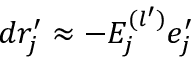<formula> <loc_0><loc_0><loc_500><loc_500>d r _ { j } ^ { \prime } \approx - E _ { j } ^ { ( l ^ { \prime } ) } e _ { j } ^ { \prime }</formula> 